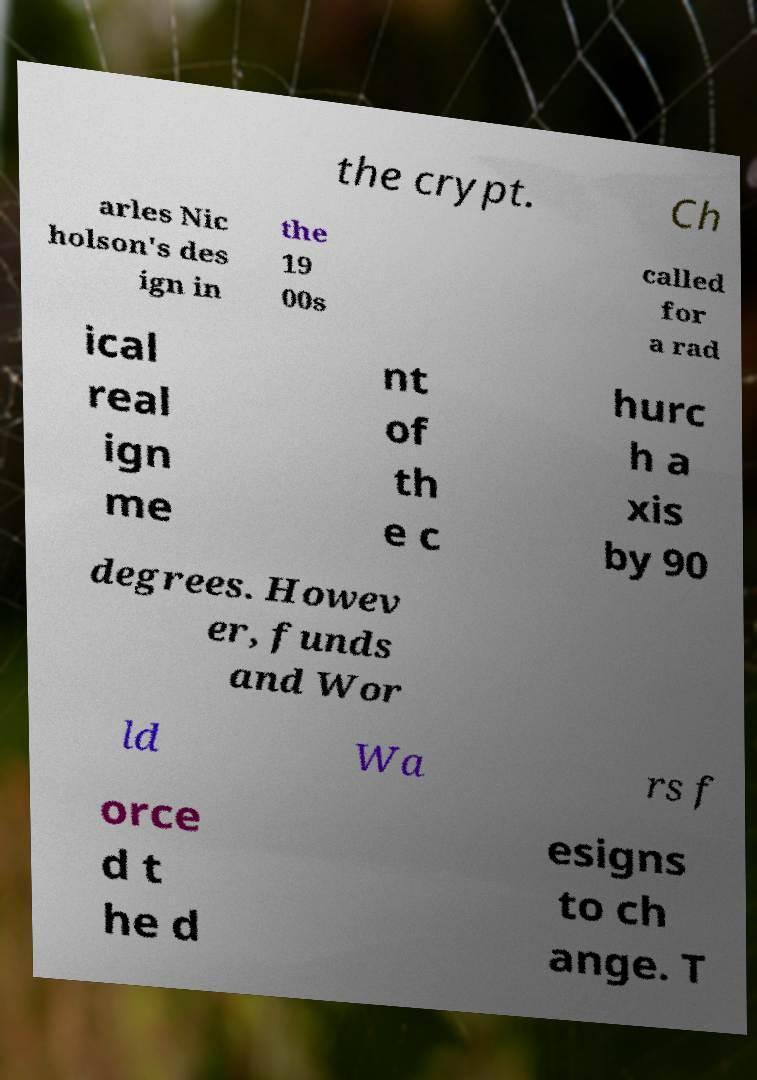For documentation purposes, I need the text within this image transcribed. Could you provide that? the crypt. Ch arles Nic holson's des ign in the 19 00s called for a rad ical real ign me nt of th e c hurc h a xis by 90 degrees. Howev er, funds and Wor ld Wa rs f orce d t he d esigns to ch ange. T 